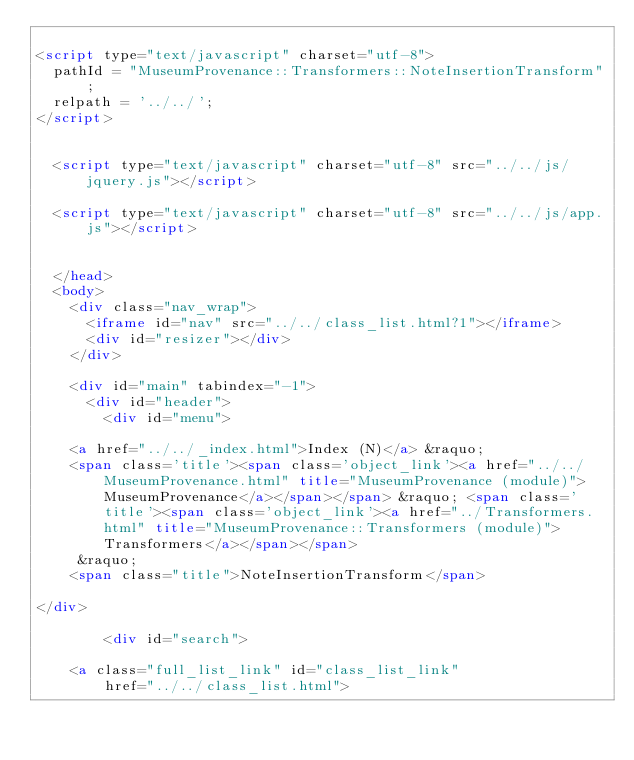Convert code to text. <code><loc_0><loc_0><loc_500><loc_500><_HTML_>
<script type="text/javascript" charset="utf-8">
  pathId = "MuseumProvenance::Transformers::NoteInsertionTransform";
  relpath = '../../';
</script>


  <script type="text/javascript" charset="utf-8" src="../../js/jquery.js"></script>

  <script type="text/javascript" charset="utf-8" src="../../js/app.js"></script>


  </head>
  <body>
    <div class="nav_wrap">
      <iframe id="nav" src="../../class_list.html?1"></iframe>
      <div id="resizer"></div>
    </div>

    <div id="main" tabindex="-1">
      <div id="header">
        <div id="menu">
  
    <a href="../../_index.html">Index (N)</a> &raquo;
    <span class='title'><span class='object_link'><a href="../../MuseumProvenance.html" title="MuseumProvenance (module)">MuseumProvenance</a></span></span> &raquo; <span class='title'><span class='object_link'><a href="../Transformers.html" title="MuseumProvenance::Transformers (module)">Transformers</a></span></span>
     &raquo; 
    <span class="title">NoteInsertionTransform</span>
  
</div>

        <div id="search">
  
    <a class="full_list_link" id="class_list_link"
        href="../../class_list.html">
</code> 